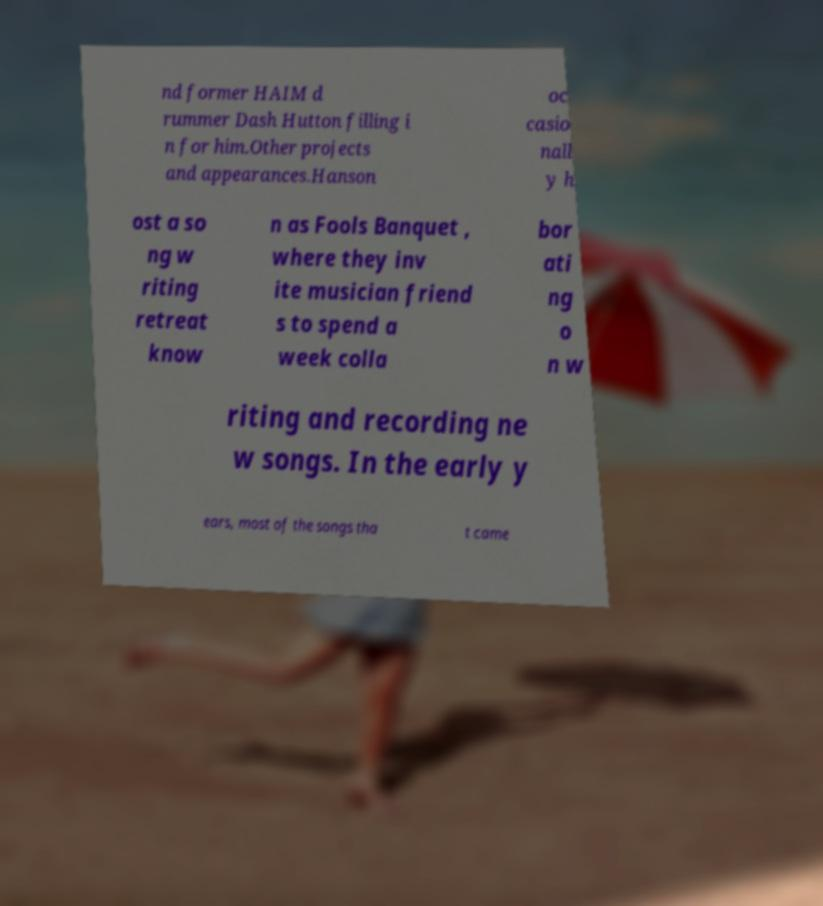Can you read and provide the text displayed in the image?This photo seems to have some interesting text. Can you extract and type it out for me? nd former HAIM d rummer Dash Hutton filling i n for him.Other projects and appearances.Hanson oc casio nall y h ost a so ng w riting retreat know n as Fools Banquet , where they inv ite musician friend s to spend a week colla bor ati ng o n w riting and recording ne w songs. In the early y ears, most of the songs tha t came 